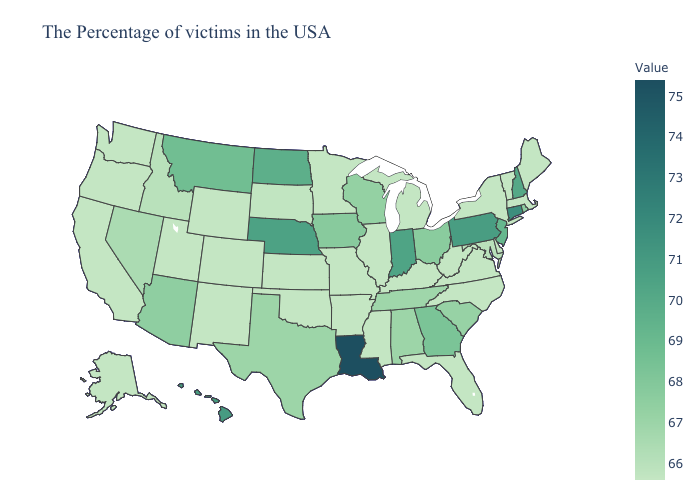Which states have the lowest value in the Northeast?
Write a very short answer. Maine, Massachusetts, Vermont, New York. Does Texas have the lowest value in the USA?
Concise answer only. No. Among the states that border Arizona , which have the lowest value?
Give a very brief answer. Colorado, New Mexico, Utah, California. Which states hav the highest value in the Northeast?
Write a very short answer. Connecticut. Does the map have missing data?
Concise answer only. No. Does Arizona have the highest value in the West?
Short answer required. No. 